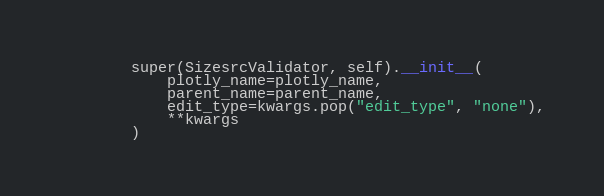<code> <loc_0><loc_0><loc_500><loc_500><_Python_>        super(SizesrcValidator, self).__init__(
            plotly_name=plotly_name,
            parent_name=parent_name,
            edit_type=kwargs.pop("edit_type", "none"),
            **kwargs
        )
</code> 